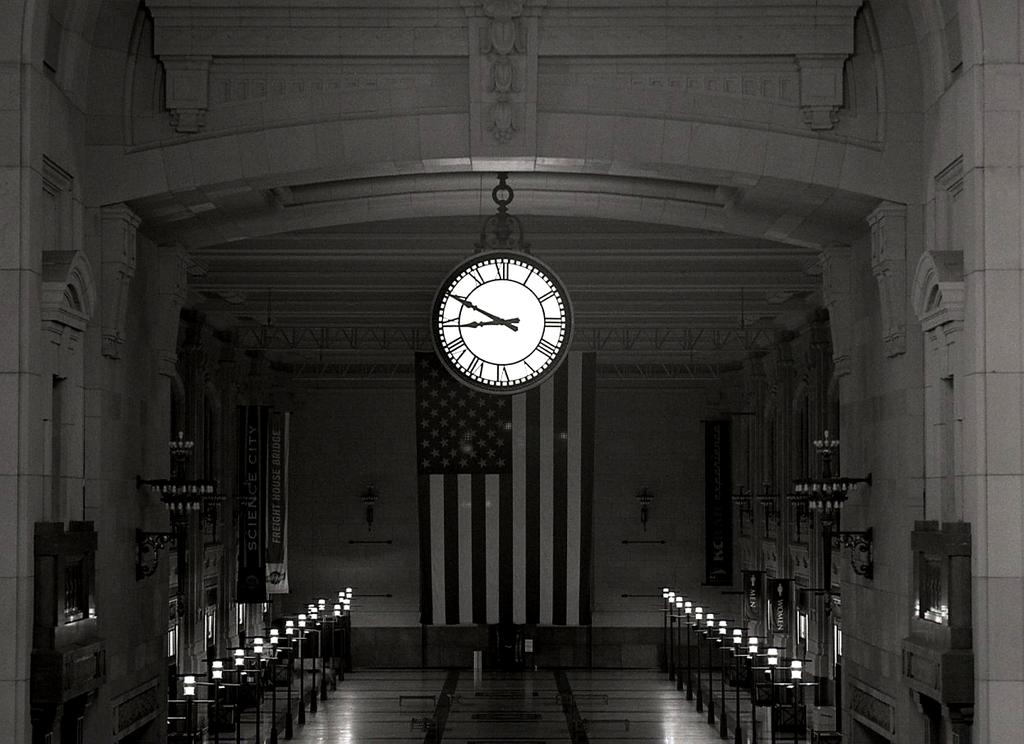Provide a one-sentence caption for the provided image. Clock inside of a building with the hands at 9 and 10. 